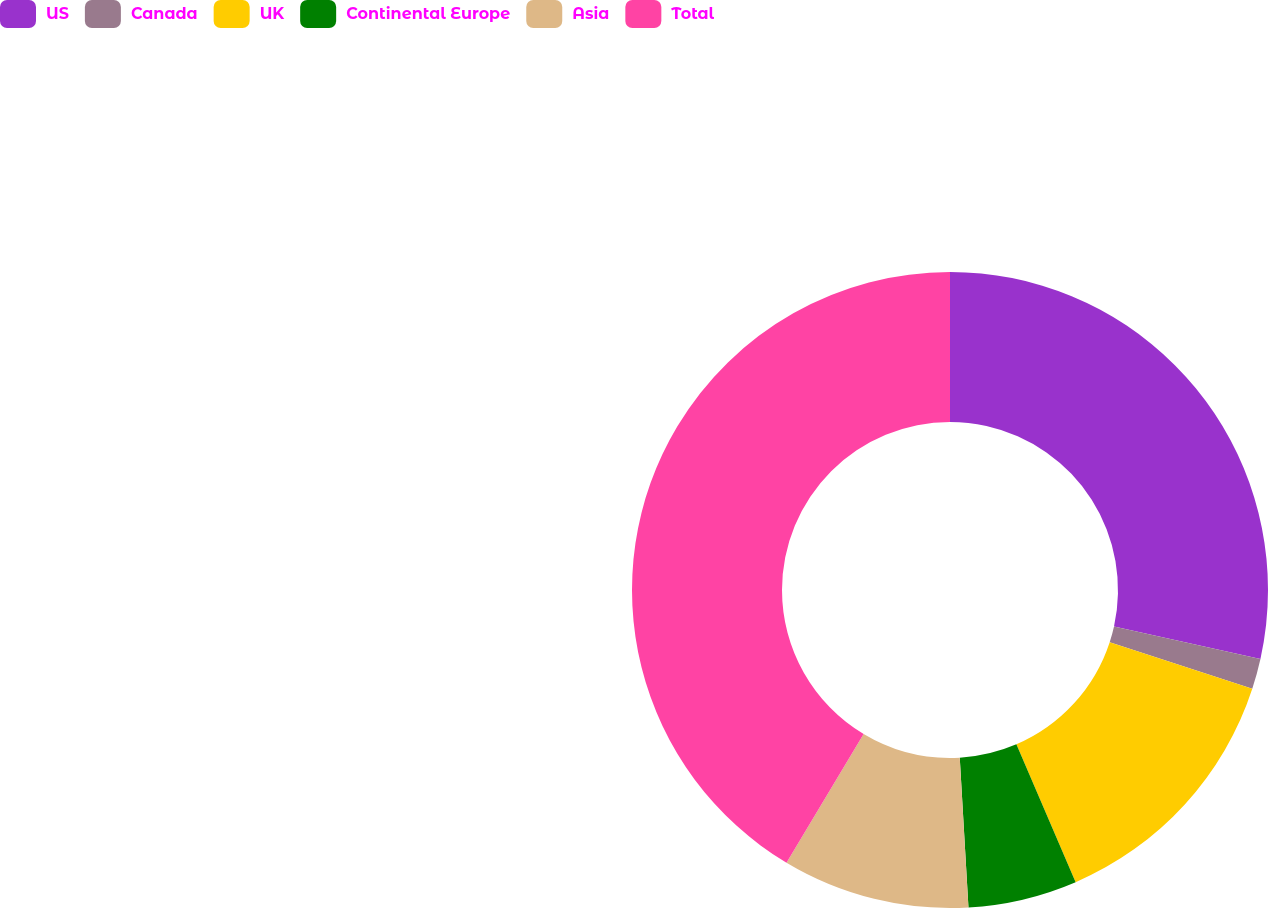<chart> <loc_0><loc_0><loc_500><loc_500><pie_chart><fcel>US<fcel>Canada<fcel>UK<fcel>Continental Europe<fcel>Asia<fcel>Total<nl><fcel>28.48%<fcel>1.55%<fcel>13.51%<fcel>5.54%<fcel>9.52%<fcel>41.41%<nl></chart> 